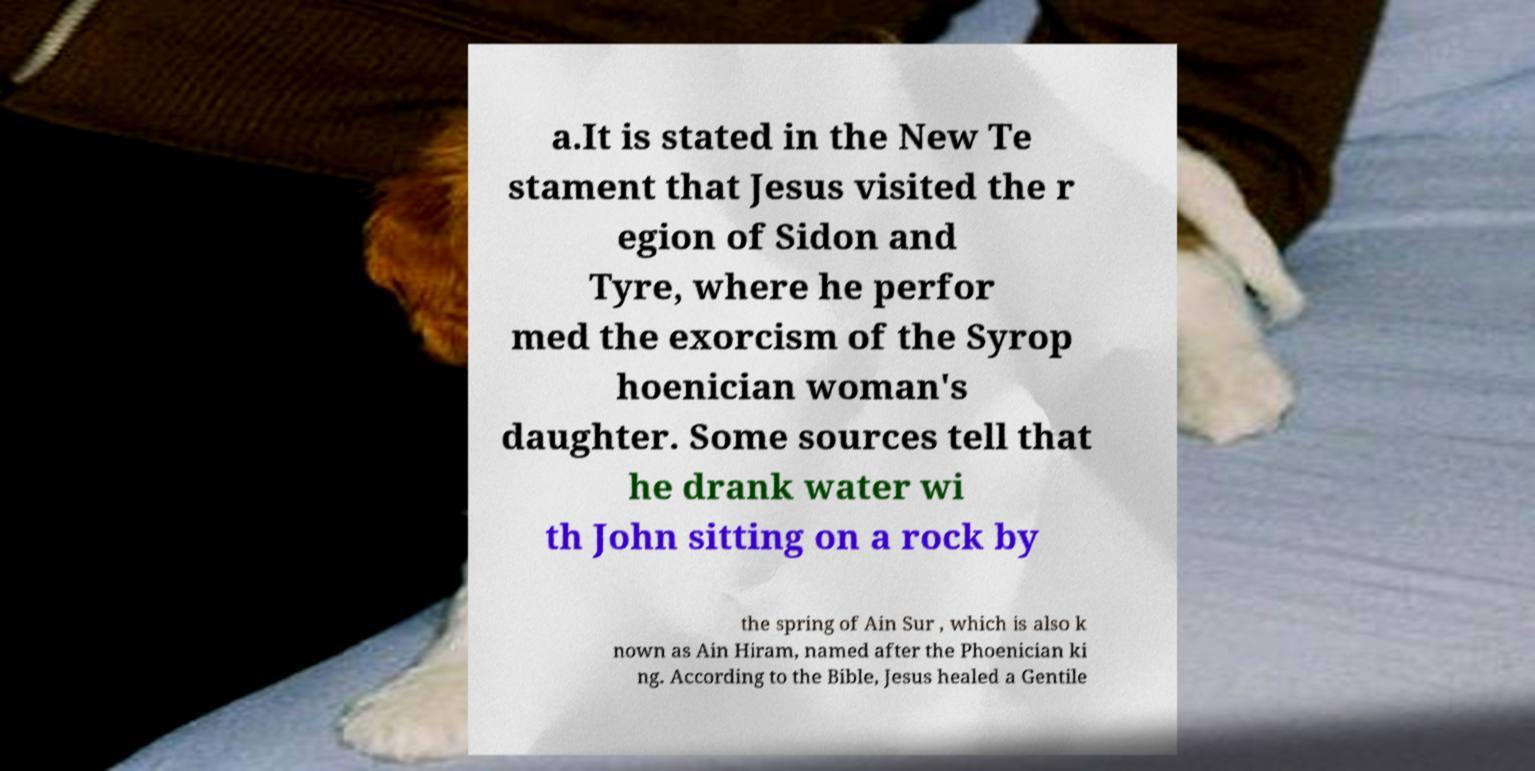I need the written content from this picture converted into text. Can you do that? a.It is stated in the New Te stament that Jesus visited the r egion of Sidon and Tyre, where he perfor med the exorcism of the Syrop hoenician woman's daughter. Some sources tell that he drank water wi th John sitting on a rock by the spring of Ain Sur , which is also k nown as Ain Hiram, named after the Phoenician ki ng. According to the Bible, Jesus healed a Gentile 